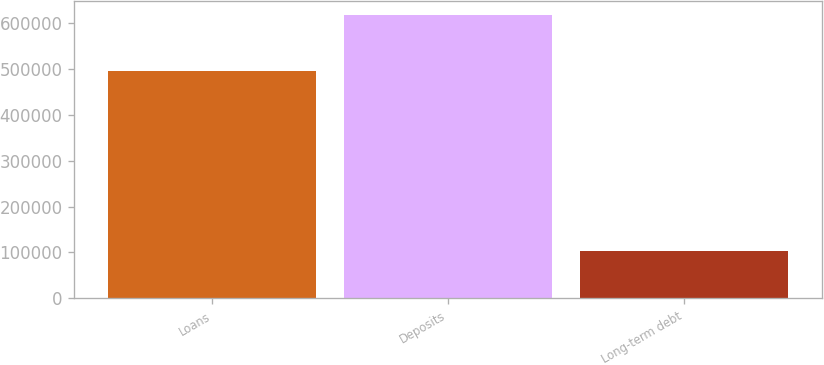<chart> <loc_0><loc_0><loc_500><loc_500><bar_chart><fcel>Loans<fcel>Deposits<fcel>Long-term debt<nl><fcel>496873<fcel>618409<fcel>102439<nl></chart> 